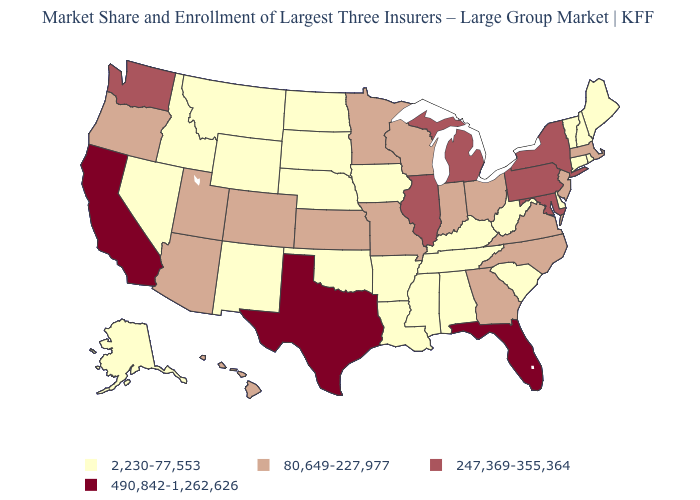Does Oregon have the highest value in the USA?
Answer briefly. No. What is the value of Illinois?
Give a very brief answer. 247,369-355,364. How many symbols are there in the legend?
Keep it brief. 4. What is the highest value in the MidWest ?
Short answer required. 247,369-355,364. What is the value of Virginia?
Short answer required. 80,649-227,977. What is the lowest value in the MidWest?
Be succinct. 2,230-77,553. Name the states that have a value in the range 2,230-77,553?
Keep it brief. Alabama, Alaska, Arkansas, Connecticut, Delaware, Idaho, Iowa, Kentucky, Louisiana, Maine, Mississippi, Montana, Nebraska, Nevada, New Hampshire, New Mexico, North Dakota, Oklahoma, Rhode Island, South Carolina, South Dakota, Tennessee, Vermont, West Virginia, Wyoming. Does Wisconsin have a lower value than Colorado?
Be succinct. No. Name the states that have a value in the range 247,369-355,364?
Short answer required. Illinois, Maryland, Michigan, New York, Pennsylvania, Washington. What is the value of North Carolina?
Give a very brief answer. 80,649-227,977. Name the states that have a value in the range 2,230-77,553?
Keep it brief. Alabama, Alaska, Arkansas, Connecticut, Delaware, Idaho, Iowa, Kentucky, Louisiana, Maine, Mississippi, Montana, Nebraska, Nevada, New Hampshire, New Mexico, North Dakota, Oklahoma, Rhode Island, South Carolina, South Dakota, Tennessee, Vermont, West Virginia, Wyoming. Among the states that border Kansas , does Colorado have the lowest value?
Write a very short answer. No. Does West Virginia have the highest value in the South?
Quick response, please. No. What is the highest value in the South ?
Concise answer only. 490,842-1,262,626. What is the value of South Carolina?
Be succinct. 2,230-77,553. 